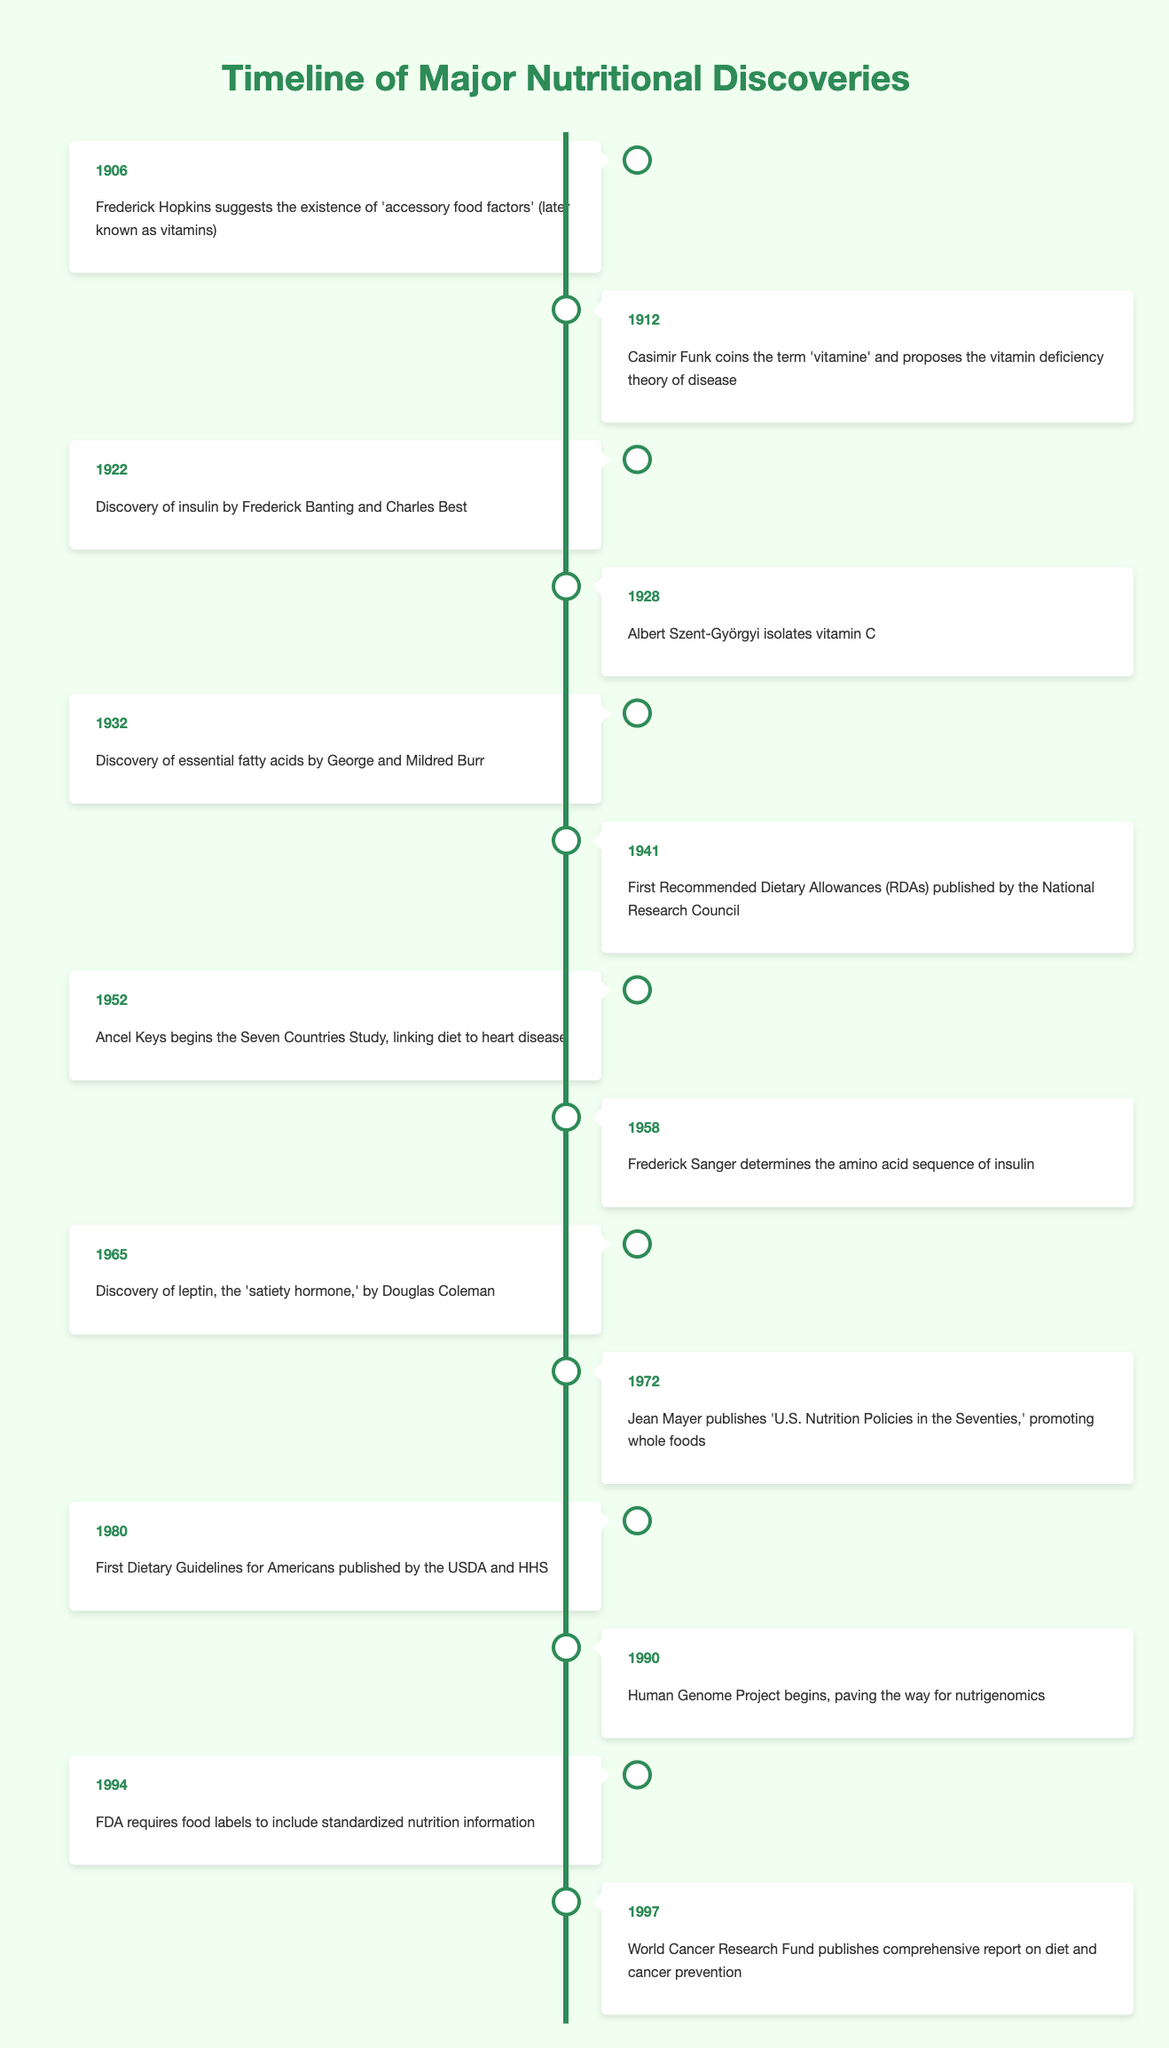What significant nutritional discovery took place in 1928? In 1928, Albert Szent-Györgyi isolated vitamin C, as noted in the timeline.
Answer: Isolation of vitamin C Which year did the first Recommended Dietary Allowances get published? The timeline indicates that the first Recommended Dietary Allowances were published in 1941.
Answer: 1941 What is the total number of events listed in the timeline? The timeline contains a total of 14 distinct nutritional discoveries spanning the years mentioned.
Answer: 14 Did Frederick Hopkins propose the existence of vitamins before or after 1920? Looking at the timeline, Frederick Hopkins suggested the existence of 'accessory food factors' in 1906, which is before 1920.
Answer: Before What year marks the beginning of the Human Genome Project? According to the timeline, the Human Genome Project began in 1990.
Answer: 1990 What year saw the publication of the first Dietary Guidelines for Americans? The timeline shows that the first Dietary Guidelines for Americans were published in 1980.
Answer: 1980 Which discovery occurred last, the isolation of vitamin C or the requirement for standardized nutrition information? From the timeline, isolation of vitamin C took place in 1928, while the requirement for standardized nutrition information was established in 1994, hence the latter occurred last.
Answer: Standardized nutrition information What is the gap in years between the discovery of insulin and the publication of the first Dietary Guidelines? The discovery of insulin occurred in 1922 and the first Dietary Guidelines were published in 1980. The gap is 1980 - 1922 = 58 years.
Answer: 58 years What was the main focus of the Seven Countries Study started in 1952? According to the timeline, Ancel Keys began the Seven Countries Study in 1952 to link diet to heart disease.
Answer: Link diet to heart disease 